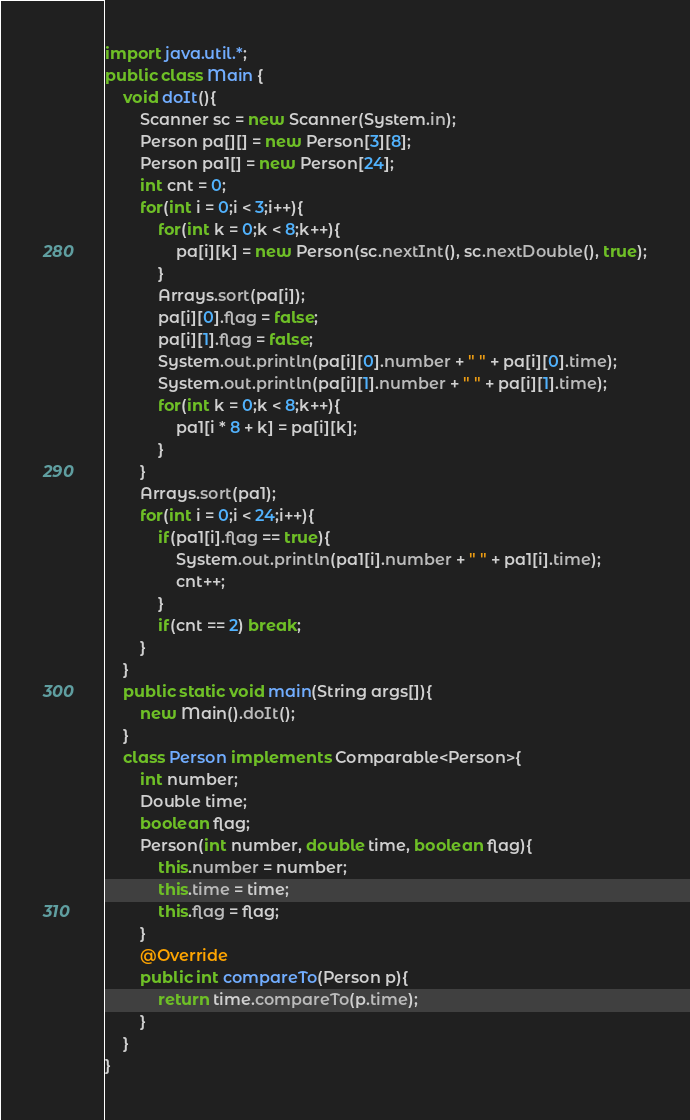<code> <loc_0><loc_0><loc_500><loc_500><_Java_>import java.util.*;
public class Main {
	void doIt(){
		Scanner sc = new Scanner(System.in);
		Person pa[][] = new Person[3][8];
		Person pa1[] = new Person[24];
		int cnt = 0;
		for(int i = 0;i < 3;i++){
			for(int k = 0;k < 8;k++){
				pa[i][k] = new Person(sc.nextInt(), sc.nextDouble(), true);
			}
			Arrays.sort(pa[i]);
			pa[i][0].flag = false;
			pa[i][1].flag = false;
			System.out.println(pa[i][0].number + " " + pa[i][0].time);
			System.out.println(pa[i][1].number + " " + pa[i][1].time);
			for(int k = 0;k < 8;k++){
				pa1[i * 8 + k] = pa[i][k];
			}
		}
		Arrays.sort(pa1);
		for(int i = 0;i < 24;i++){
			if(pa1[i].flag == true){
				System.out.println(pa1[i].number + " " + pa1[i].time);
				cnt++;		
			}
			if(cnt == 2) break;
		}
	}
	public static void main(String args[]){
		new Main().doIt();
	}
	class Person implements Comparable<Person>{ 
		int number;
		Double time;
		boolean flag;
		Person(int number, double time, boolean flag){
			this.number = number;
			this.time = time;
			this.flag = flag;
		}
		@Override
		public int compareTo(Person p){
			return time.compareTo(p.time);
		}
	}
}</code> 